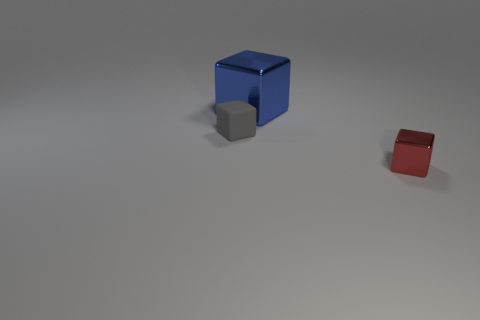Is there any other thing that is made of the same material as the gray block?
Provide a short and direct response. No. What number of small red metallic things are on the right side of the small matte cube?
Ensure brevity in your answer.  1. How many other objects are the same size as the red cube?
Offer a very short reply. 1. Do the small block on the left side of the tiny red metal thing and the object that is right of the blue block have the same material?
Make the answer very short. No. What is the color of the cube that is the same size as the gray object?
Offer a terse response. Red. Is there any other thing that has the same color as the tiny matte thing?
Your response must be concise. No. There is a metallic cube right of the metallic object behind the small object behind the small metallic thing; how big is it?
Make the answer very short. Small. What is the color of the cube that is left of the red object and on the right side of the tiny matte thing?
Ensure brevity in your answer.  Blue. There is a cube to the left of the large object; what is its size?
Keep it short and to the point. Small. How many small gray objects are made of the same material as the gray block?
Ensure brevity in your answer.  0. 